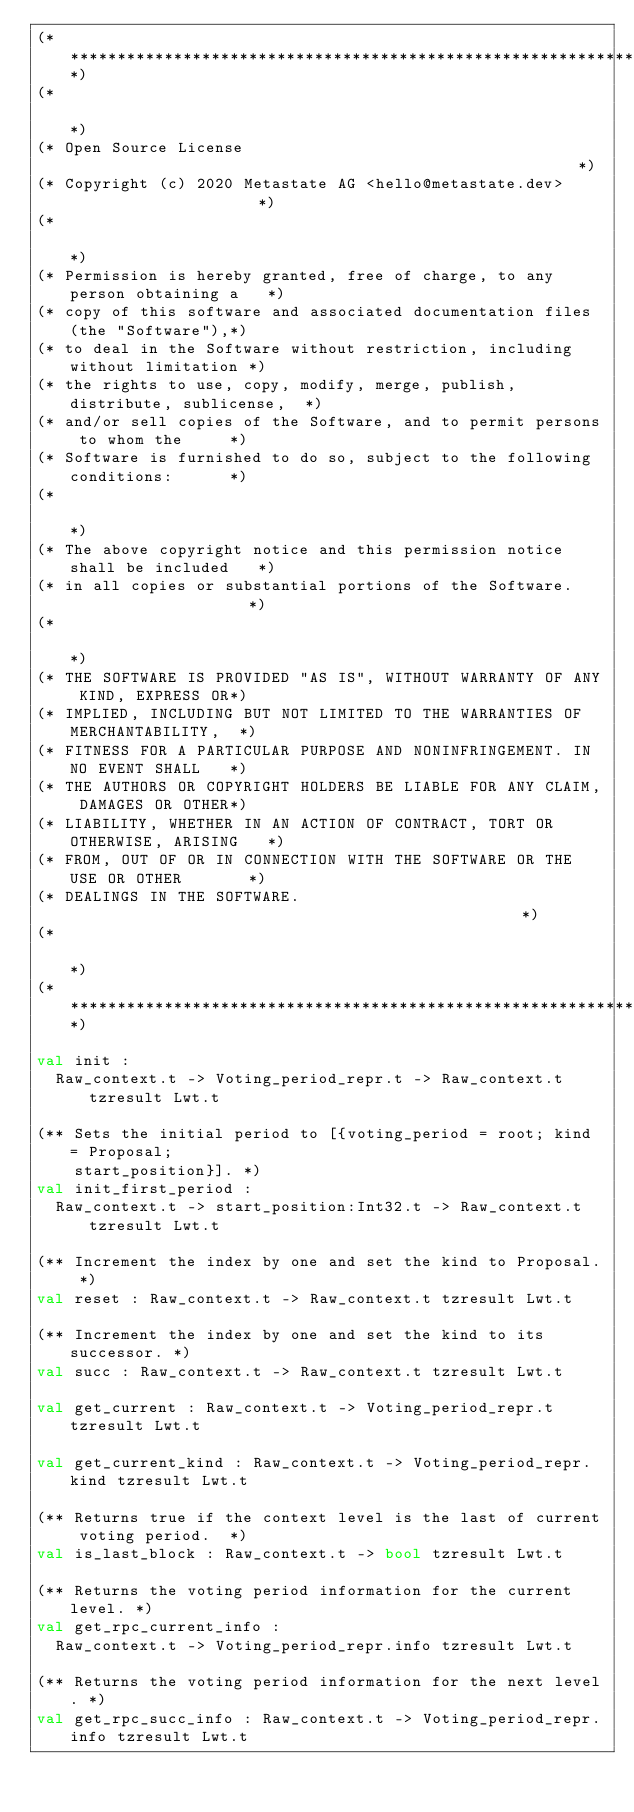<code> <loc_0><loc_0><loc_500><loc_500><_OCaml_>(*****************************************************************************)
(*                                                                           *)
(* Open Source License                                                       *)
(* Copyright (c) 2020 Metastate AG <hello@metastate.dev>                     *)
(*                                                                           *)
(* Permission is hereby granted, free of charge, to any person obtaining a   *)
(* copy of this software and associated documentation files (the "Software"),*)
(* to deal in the Software without restriction, including without limitation *)
(* the rights to use, copy, modify, merge, publish, distribute, sublicense,  *)
(* and/or sell copies of the Software, and to permit persons to whom the     *)
(* Software is furnished to do so, subject to the following conditions:      *)
(*                                                                           *)
(* The above copyright notice and this permission notice shall be included   *)
(* in all copies or substantial portions of the Software.                    *)
(*                                                                           *)
(* THE SOFTWARE IS PROVIDED "AS IS", WITHOUT WARRANTY OF ANY KIND, EXPRESS OR*)
(* IMPLIED, INCLUDING BUT NOT LIMITED TO THE WARRANTIES OF MERCHANTABILITY,  *)
(* FITNESS FOR A PARTICULAR PURPOSE AND NONINFRINGEMENT. IN NO EVENT SHALL   *)
(* THE AUTHORS OR COPYRIGHT HOLDERS BE LIABLE FOR ANY CLAIM, DAMAGES OR OTHER*)
(* LIABILITY, WHETHER IN AN ACTION OF CONTRACT, TORT OR OTHERWISE, ARISING   *)
(* FROM, OUT OF OR IN CONNECTION WITH THE SOFTWARE OR THE USE OR OTHER       *)
(* DEALINGS IN THE SOFTWARE.                                                 *)
(*                                                                           *)
(*****************************************************************************)

val init :
  Raw_context.t -> Voting_period_repr.t -> Raw_context.t tzresult Lwt.t

(** Sets the initial period to [{voting_period = root; kind = Proposal;
    start_position}]. *)
val init_first_period :
  Raw_context.t -> start_position:Int32.t -> Raw_context.t tzresult Lwt.t

(** Increment the index by one and set the kind to Proposal. *)
val reset : Raw_context.t -> Raw_context.t tzresult Lwt.t

(** Increment the index by one and set the kind to its successor. *)
val succ : Raw_context.t -> Raw_context.t tzresult Lwt.t

val get_current : Raw_context.t -> Voting_period_repr.t tzresult Lwt.t

val get_current_kind : Raw_context.t -> Voting_period_repr.kind tzresult Lwt.t

(** Returns true if the context level is the last of current voting period.  *)
val is_last_block : Raw_context.t -> bool tzresult Lwt.t

(** Returns the voting period information for the current level. *)
val get_rpc_current_info :
  Raw_context.t -> Voting_period_repr.info tzresult Lwt.t

(** Returns the voting period information for the next level. *)
val get_rpc_succ_info : Raw_context.t -> Voting_period_repr.info tzresult Lwt.t
</code> 